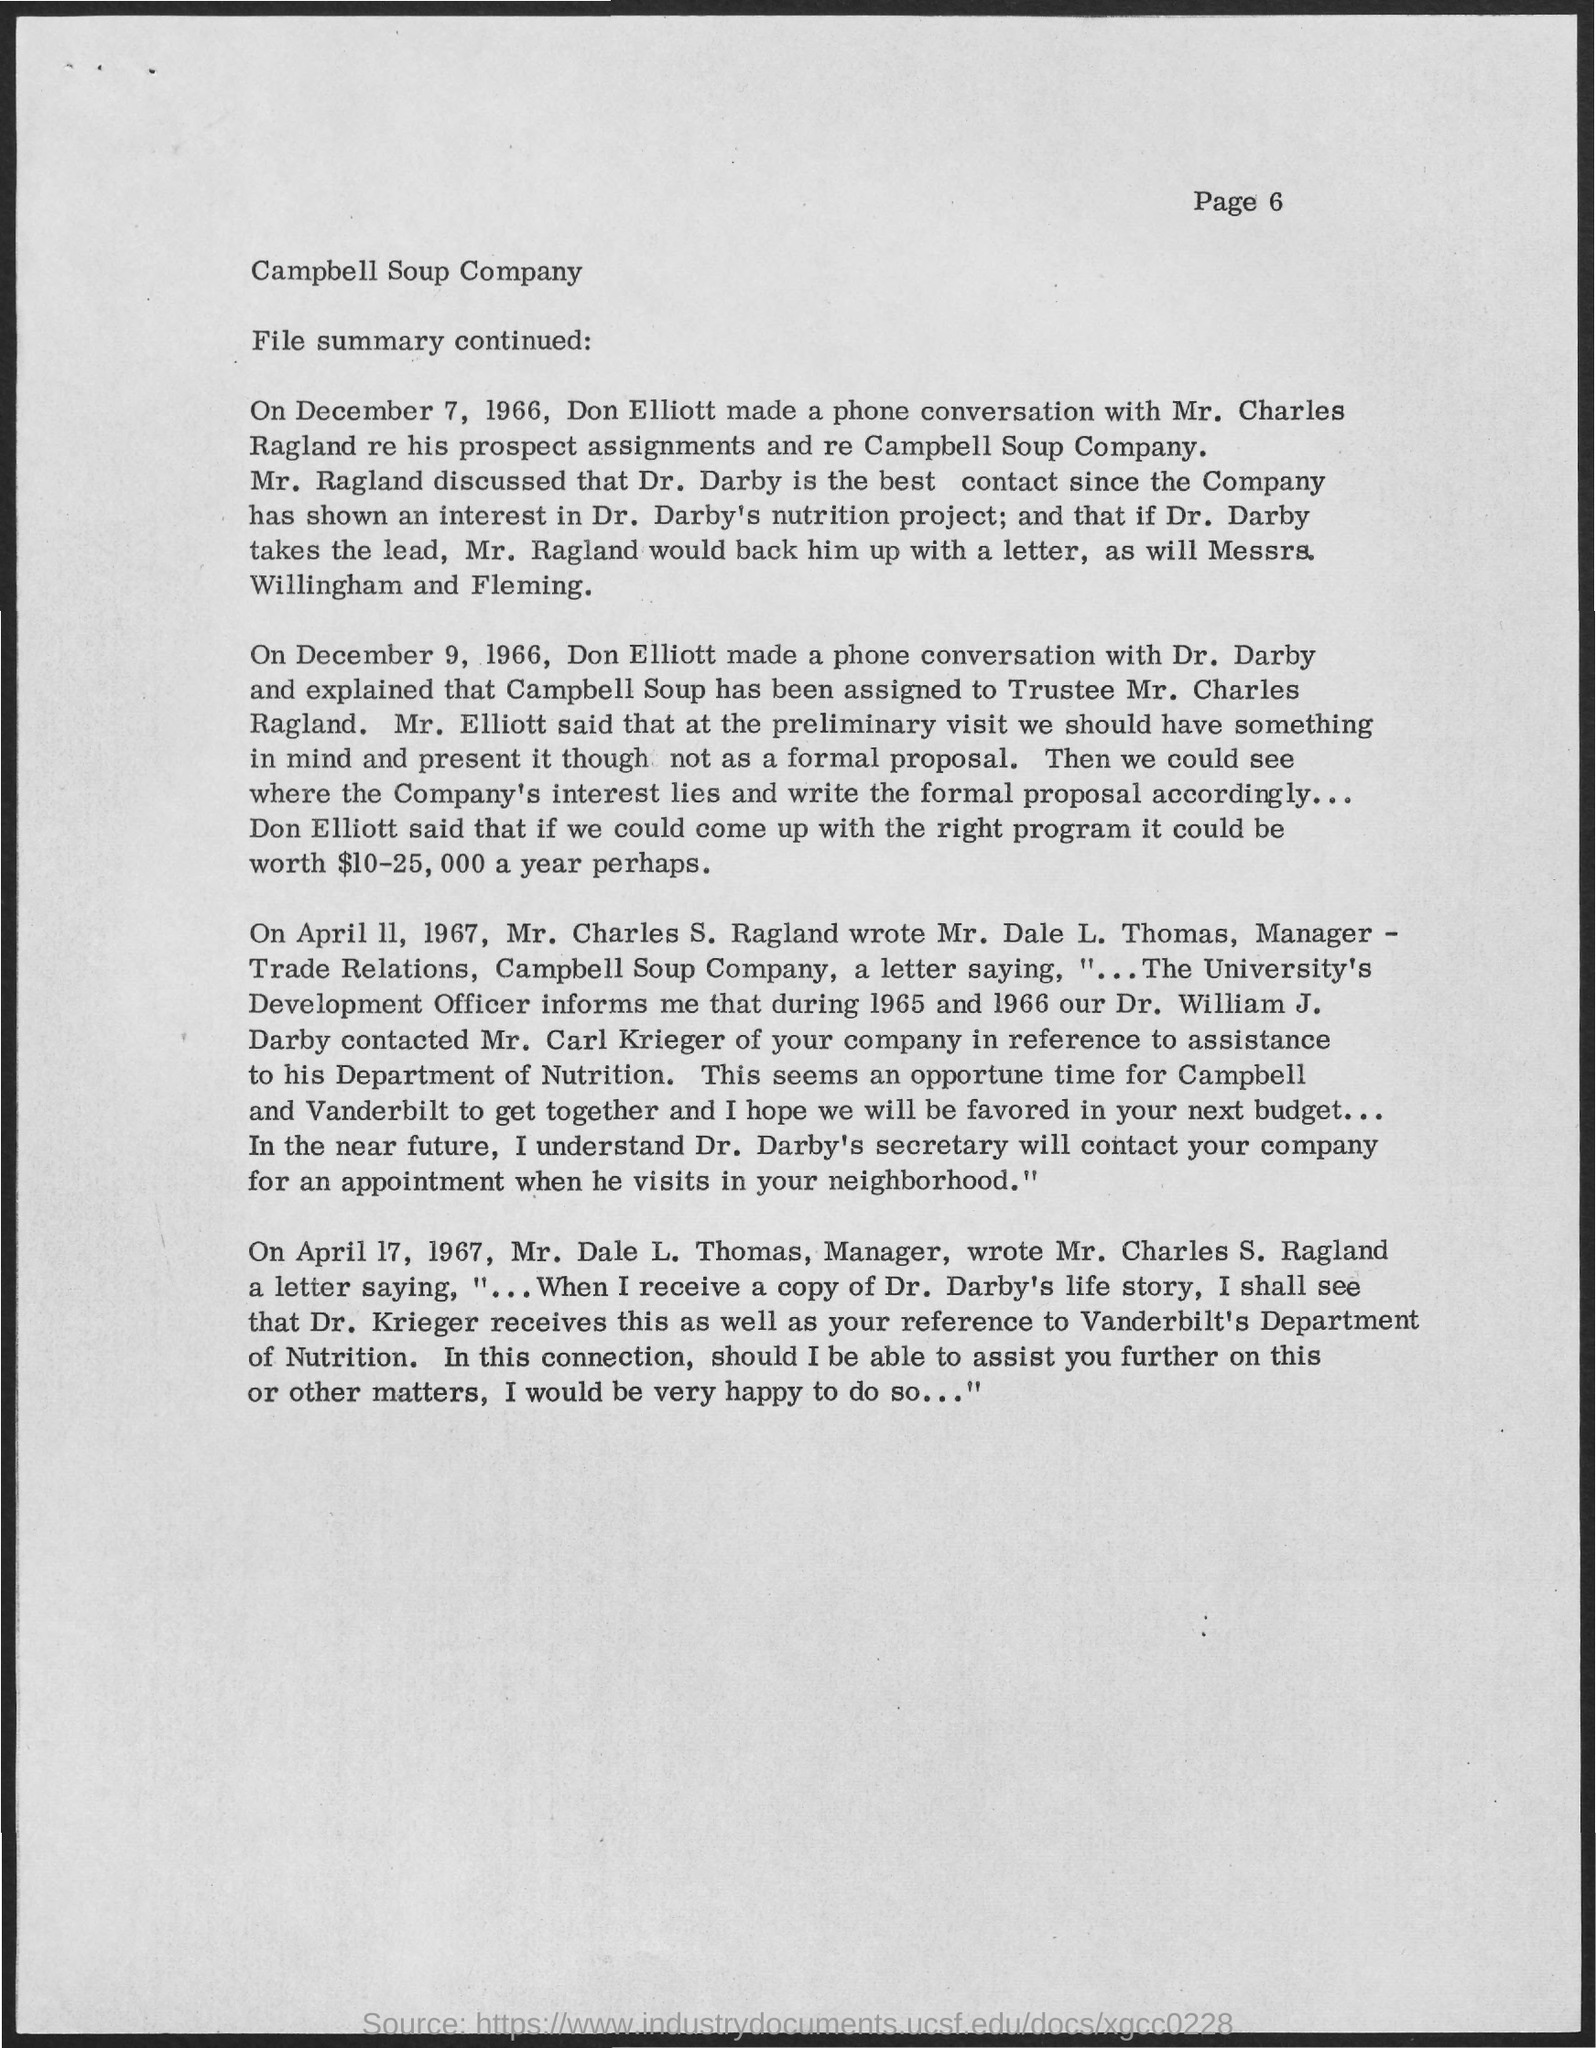Specify some key components in this picture. On December 9, 1966, Don Elliott made a phone conversation with Dr. Darby. It is known that Mr. Elliott had a phone conversation with Mr. Charles Ragland on December 7, 1966. The page number mentioned is 6. Campbell Soup Company is managed by Dale L. Thomas. 